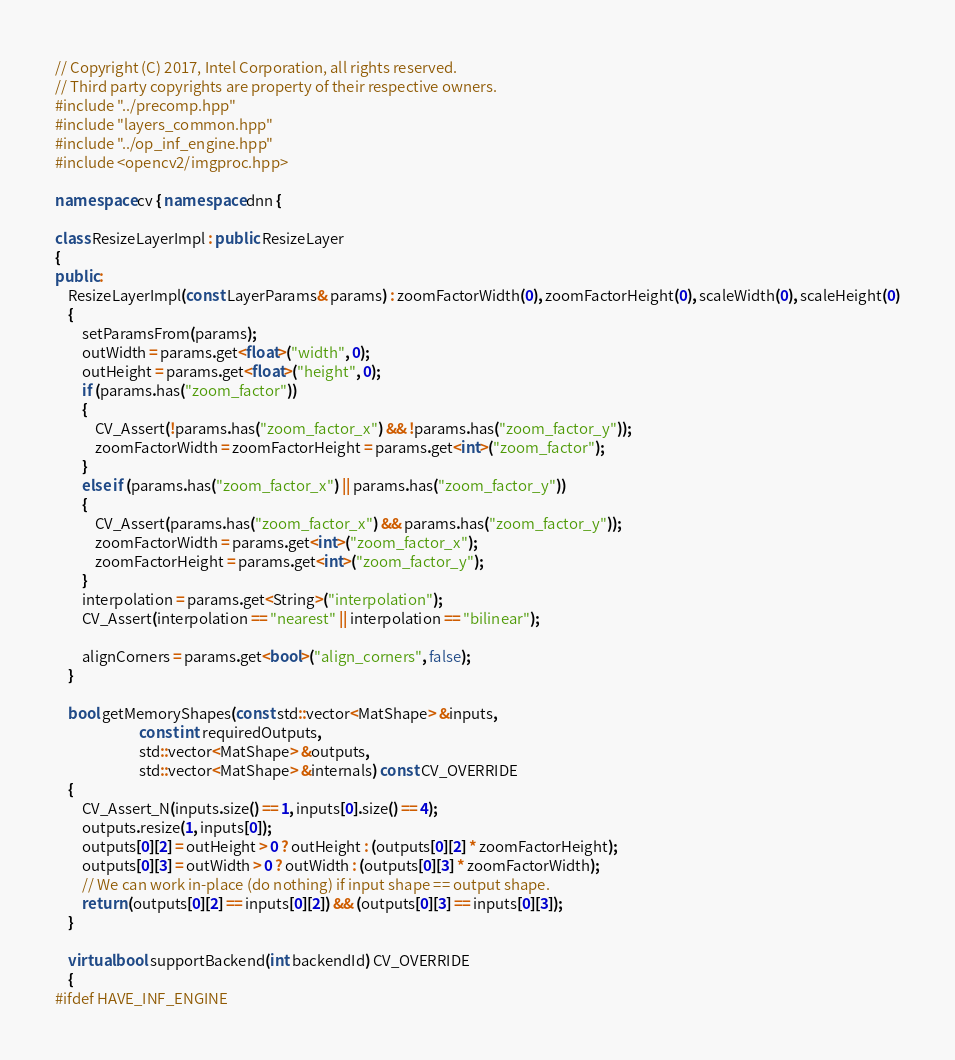Convert code to text. <code><loc_0><loc_0><loc_500><loc_500><_C++_>
// Copyright (C) 2017, Intel Corporation, all rights reserved.
// Third party copyrights are property of their respective owners.
#include "../precomp.hpp"
#include "layers_common.hpp"
#include "../op_inf_engine.hpp"
#include <opencv2/imgproc.hpp>

namespace cv { namespace dnn {

class ResizeLayerImpl : public ResizeLayer
{
public:
    ResizeLayerImpl(const LayerParams& params) : zoomFactorWidth(0), zoomFactorHeight(0), scaleWidth(0), scaleHeight(0)
    {
        setParamsFrom(params);
        outWidth = params.get<float>("width", 0);
        outHeight = params.get<float>("height", 0);
        if (params.has("zoom_factor"))
        {
            CV_Assert(!params.has("zoom_factor_x") && !params.has("zoom_factor_y"));
            zoomFactorWidth = zoomFactorHeight = params.get<int>("zoom_factor");
        }
        else if (params.has("zoom_factor_x") || params.has("zoom_factor_y"))
        {
            CV_Assert(params.has("zoom_factor_x") && params.has("zoom_factor_y"));
            zoomFactorWidth = params.get<int>("zoom_factor_x");
            zoomFactorHeight = params.get<int>("zoom_factor_y");
        }
        interpolation = params.get<String>("interpolation");
        CV_Assert(interpolation == "nearest" || interpolation == "bilinear");

        alignCorners = params.get<bool>("align_corners", false);
    }

    bool getMemoryShapes(const std::vector<MatShape> &inputs,
                         const int requiredOutputs,
                         std::vector<MatShape> &outputs,
                         std::vector<MatShape> &internals) const CV_OVERRIDE
    {
        CV_Assert_N(inputs.size() == 1, inputs[0].size() == 4);
        outputs.resize(1, inputs[0]);
        outputs[0][2] = outHeight > 0 ? outHeight : (outputs[0][2] * zoomFactorHeight);
        outputs[0][3] = outWidth > 0 ? outWidth : (outputs[0][3] * zoomFactorWidth);
        // We can work in-place (do nothing) if input shape == output shape.
        return (outputs[0][2] == inputs[0][2]) && (outputs[0][3] == inputs[0][3]);
    }

    virtual bool supportBackend(int backendId) CV_OVERRIDE
    {
#ifdef HAVE_INF_ENGINE</code> 